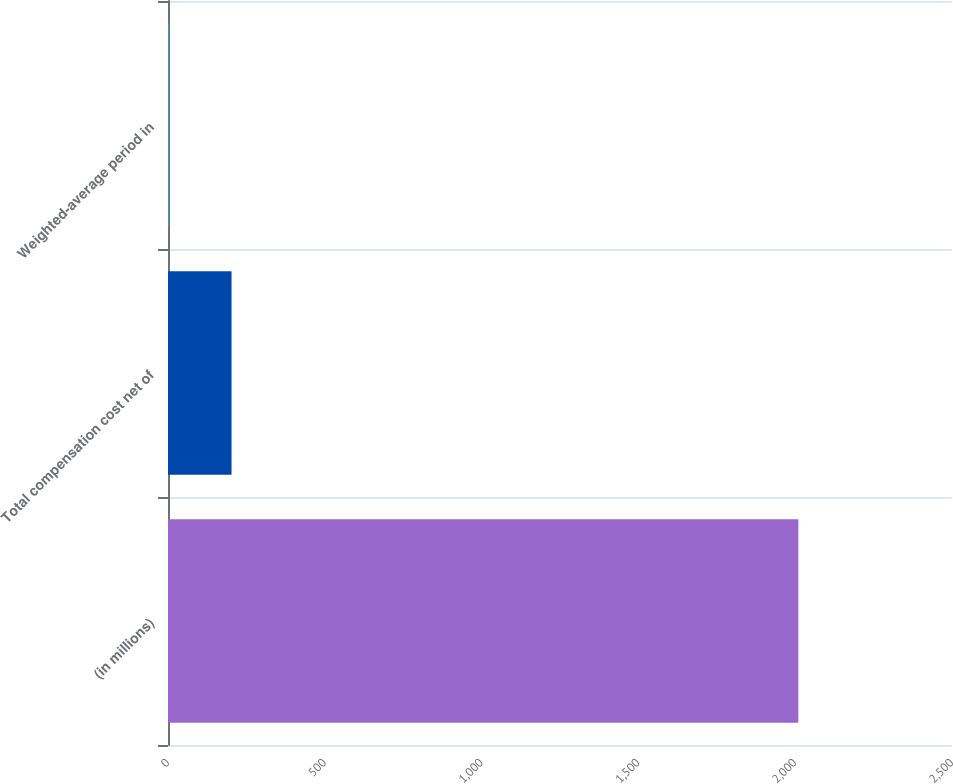<chart> <loc_0><loc_0><loc_500><loc_500><bar_chart><fcel>(in millions)<fcel>Total compensation cost net of<fcel>Weighted-average period in<nl><fcel>2010<fcel>202.62<fcel>1.8<nl></chart> 